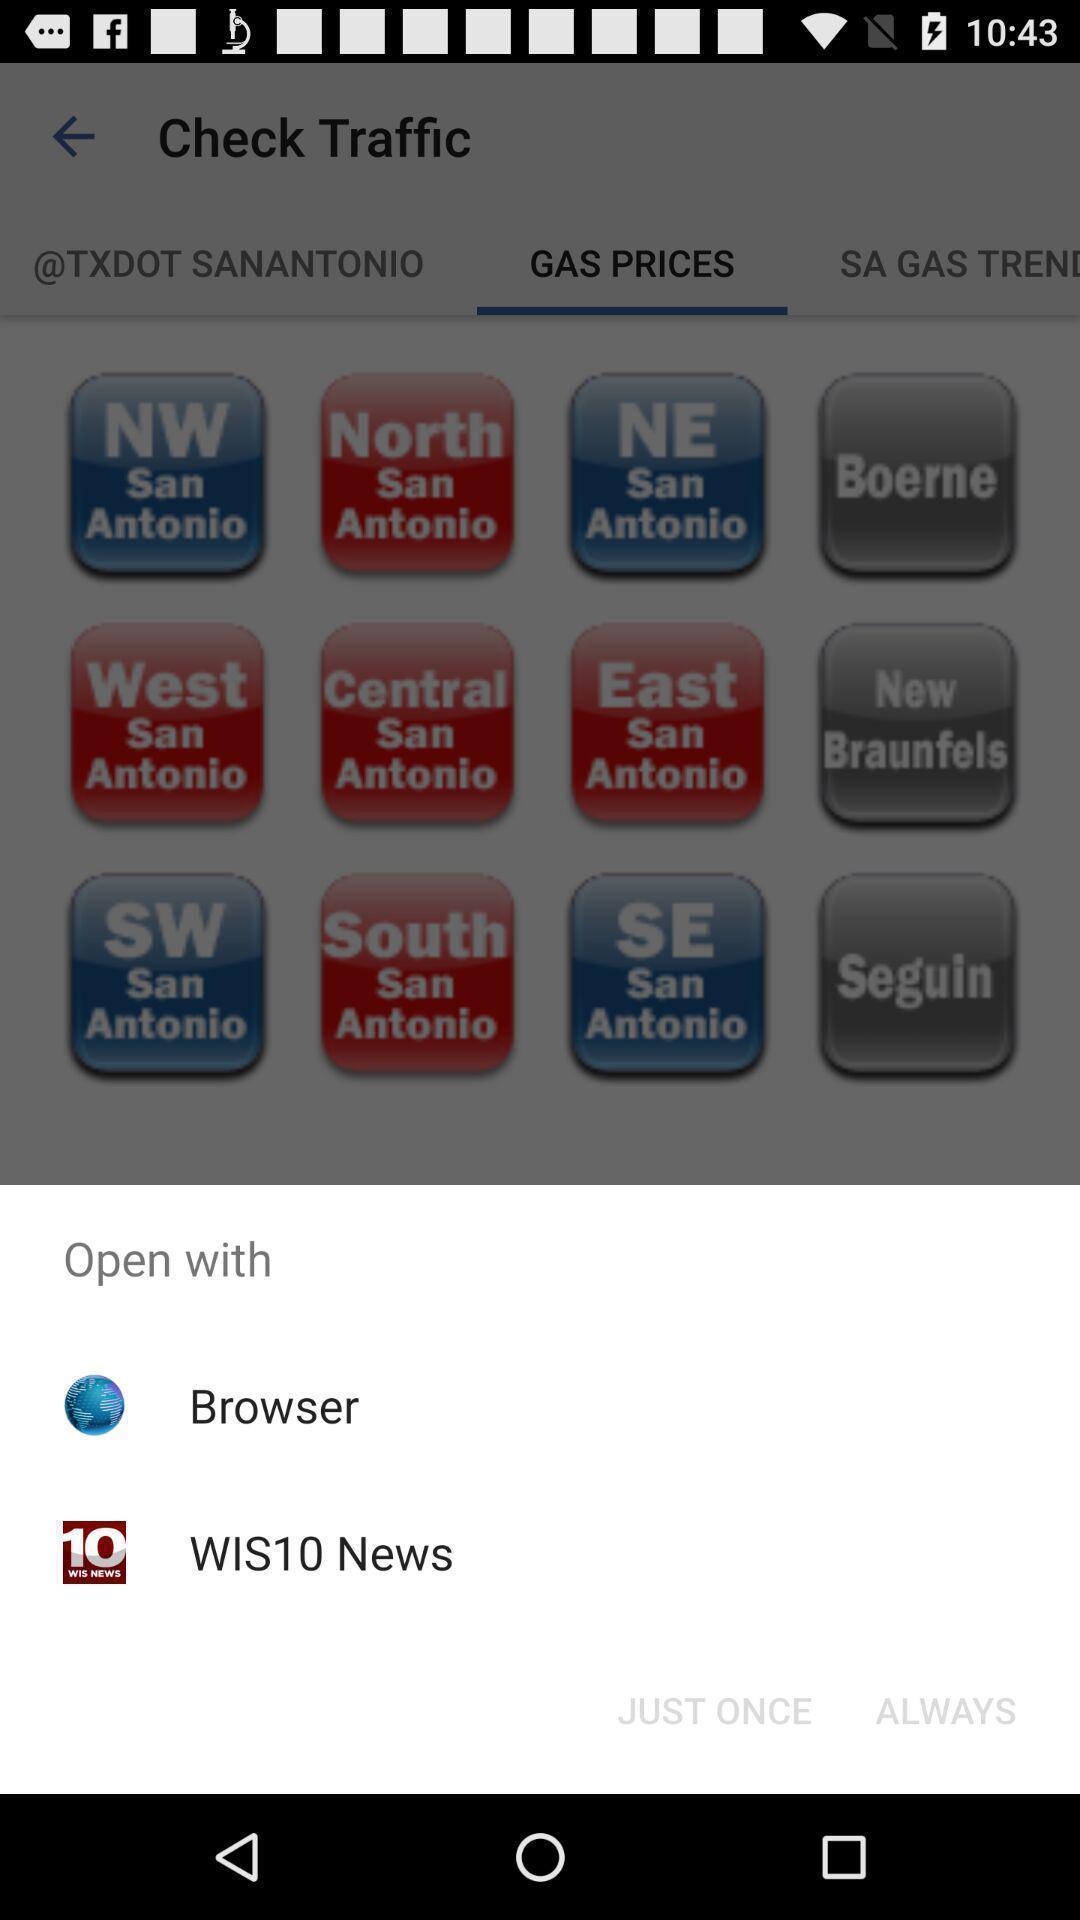Tell me what you see in this picture. Pop-up widget is displaying two browsing options. 